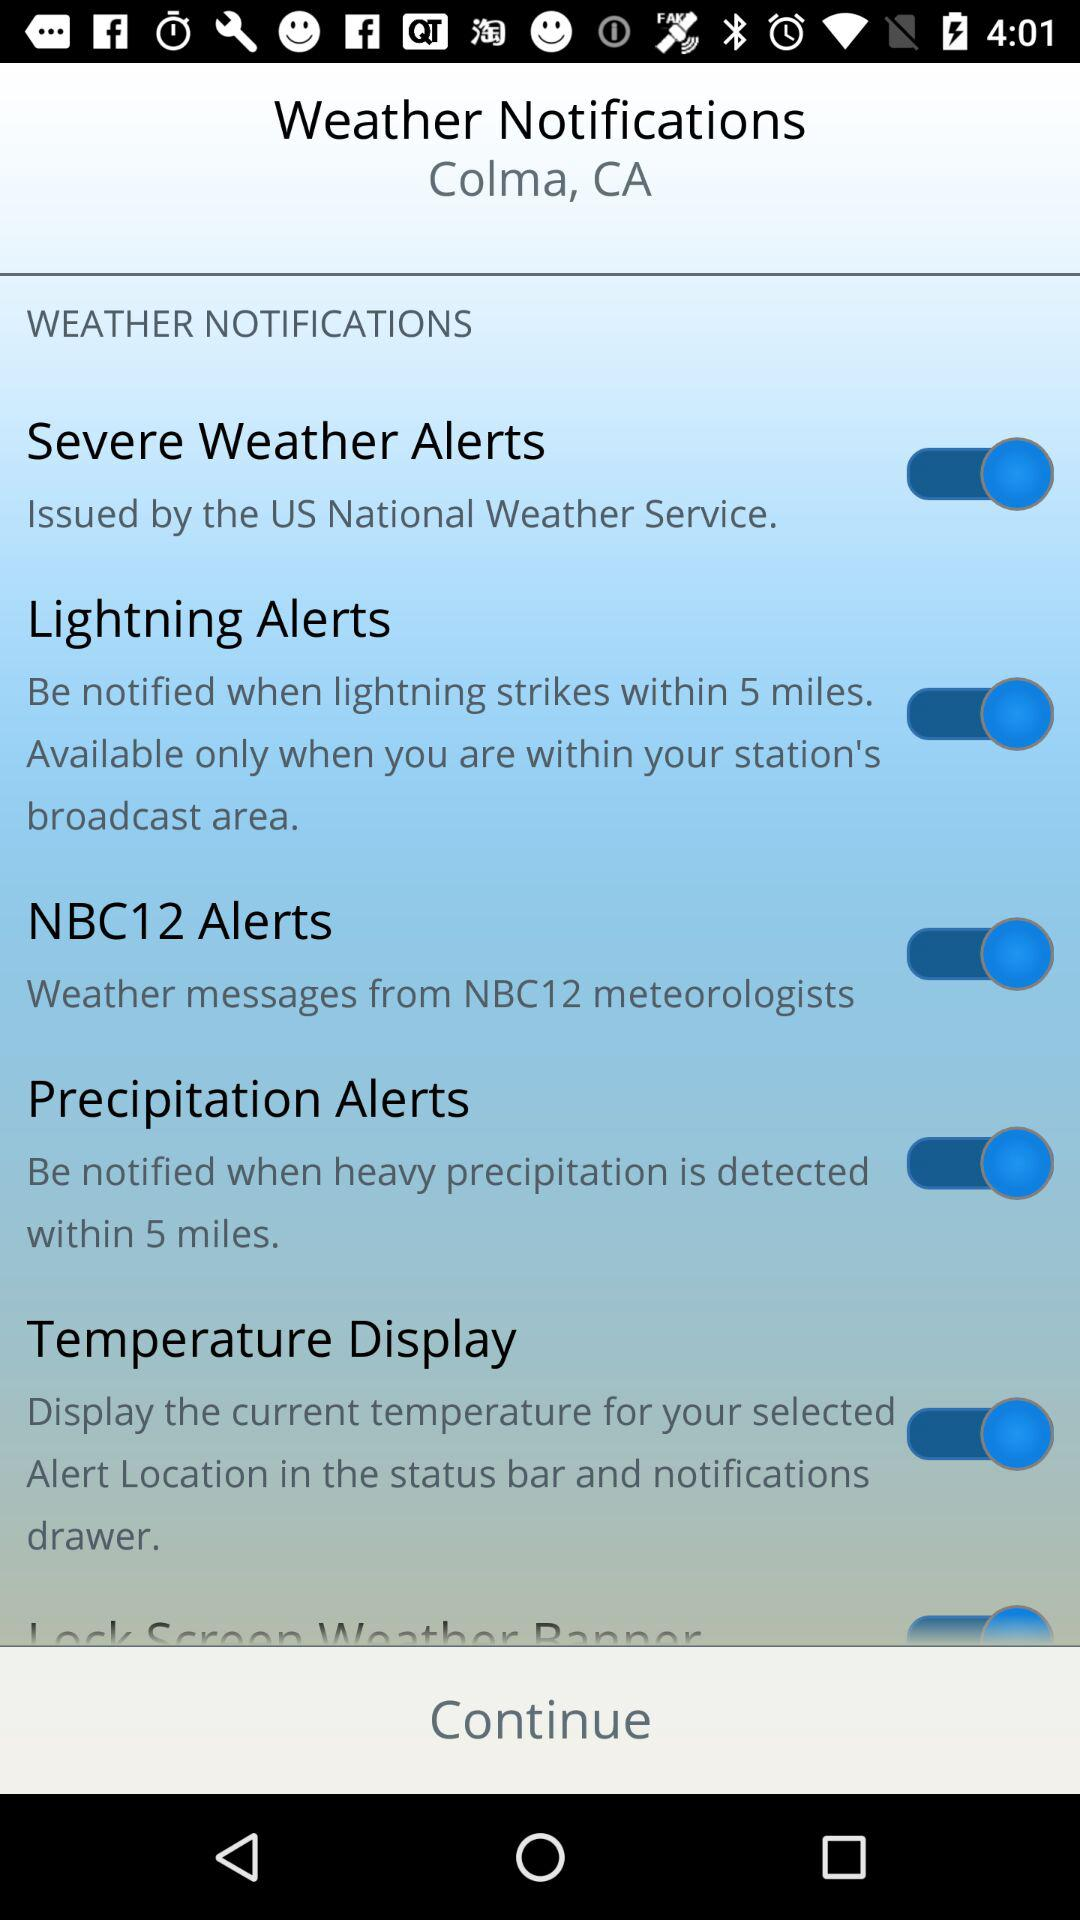What are the "Weather notification" settings options? The options are "Severe weather alerts", "Lightning alerts", "NBC12 alerts", "Precipitation alerts" and "Temperature display". 